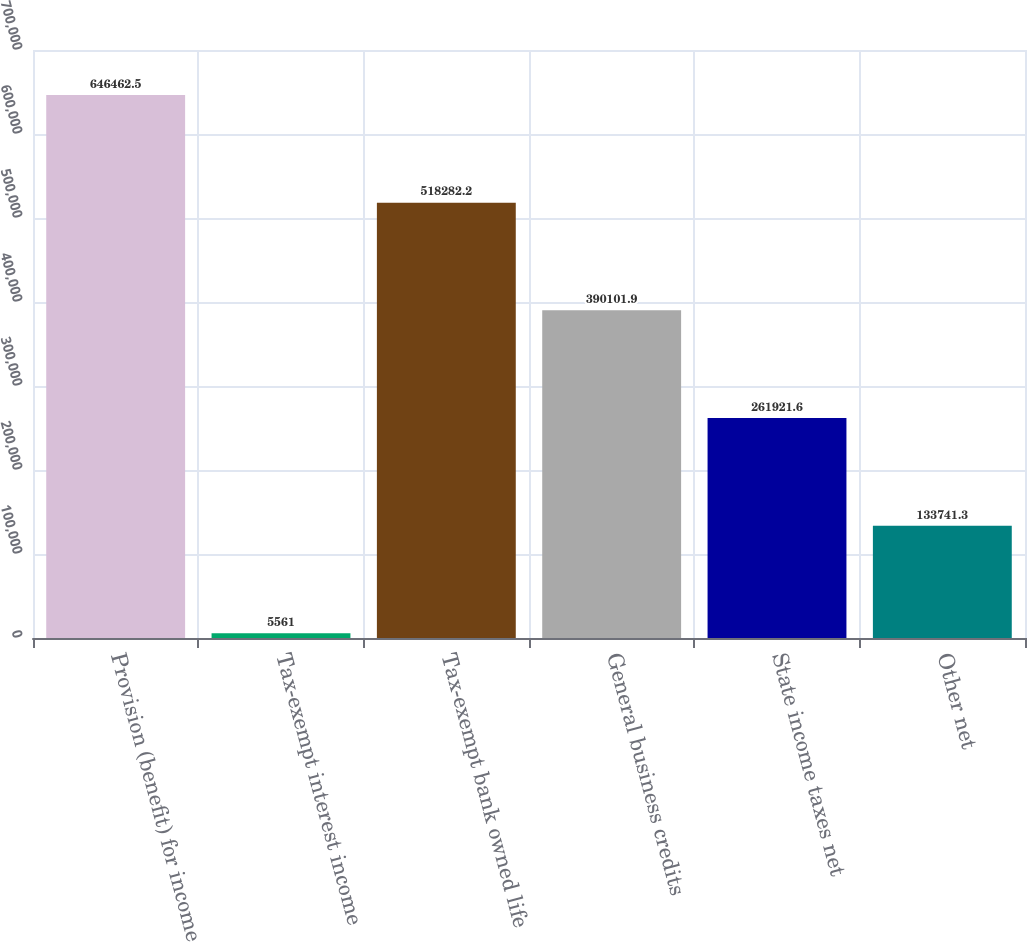Convert chart. <chart><loc_0><loc_0><loc_500><loc_500><bar_chart><fcel>Provision (benefit) for income<fcel>Tax-exempt interest income<fcel>Tax-exempt bank owned life<fcel>General business credits<fcel>State income taxes net<fcel>Other net<nl><fcel>646462<fcel>5561<fcel>518282<fcel>390102<fcel>261922<fcel>133741<nl></chart> 